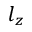<formula> <loc_0><loc_0><loc_500><loc_500>l _ { z }</formula> 